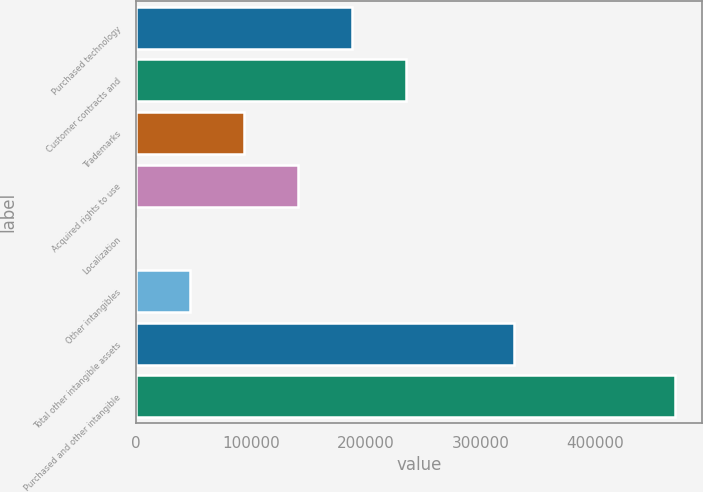<chart> <loc_0><loc_0><loc_500><loc_500><bar_chart><fcel>Purchased technology<fcel>Customer contracts and<fcel>Trademarks<fcel>Acquired rights to use<fcel>Localization<fcel>Other intangibles<fcel>Total other intangible assets<fcel>Purchased and other intangible<nl><fcel>187965<fcel>234914<fcel>94066<fcel>141016<fcel>167<fcel>47116.5<fcel>329151<fcel>469662<nl></chart> 